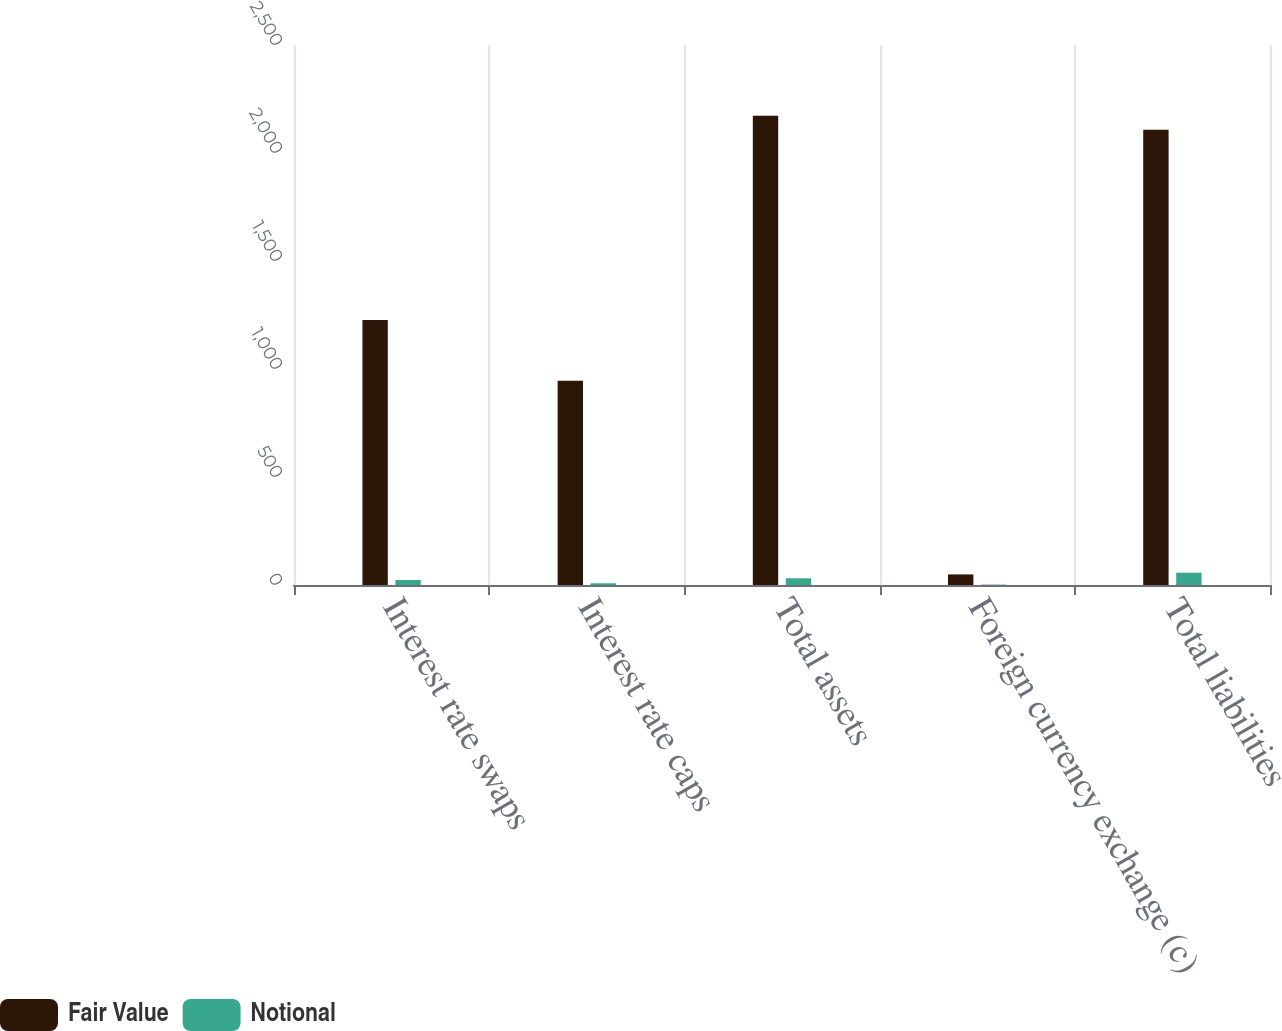Convert chart to OTSL. <chart><loc_0><loc_0><loc_500><loc_500><stacked_bar_chart><ecel><fcel>Interest rate swaps<fcel>Interest rate caps<fcel>Total assets<fcel>Foreign currency exchange (c)<fcel>Total liabilities<nl><fcel>Fair Value<fcel>1227<fcel>946<fcel>2173<fcel>49<fcel>2108<nl><fcel>Notional<fcel>23<fcel>8<fcel>31<fcel>2<fcel>57<nl></chart> 